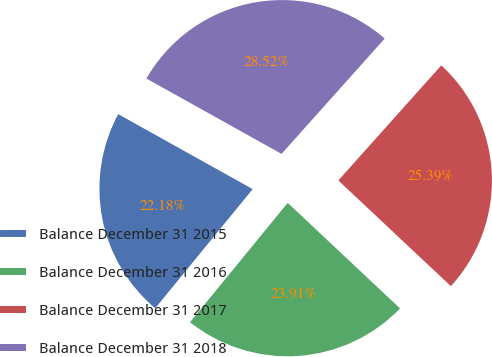Convert chart to OTSL. <chart><loc_0><loc_0><loc_500><loc_500><pie_chart><fcel>Balance December 31 2015<fcel>Balance December 31 2016<fcel>Balance December 31 2017<fcel>Balance December 31 2018<nl><fcel>22.18%<fcel>23.91%<fcel>25.39%<fcel>28.52%<nl></chart> 